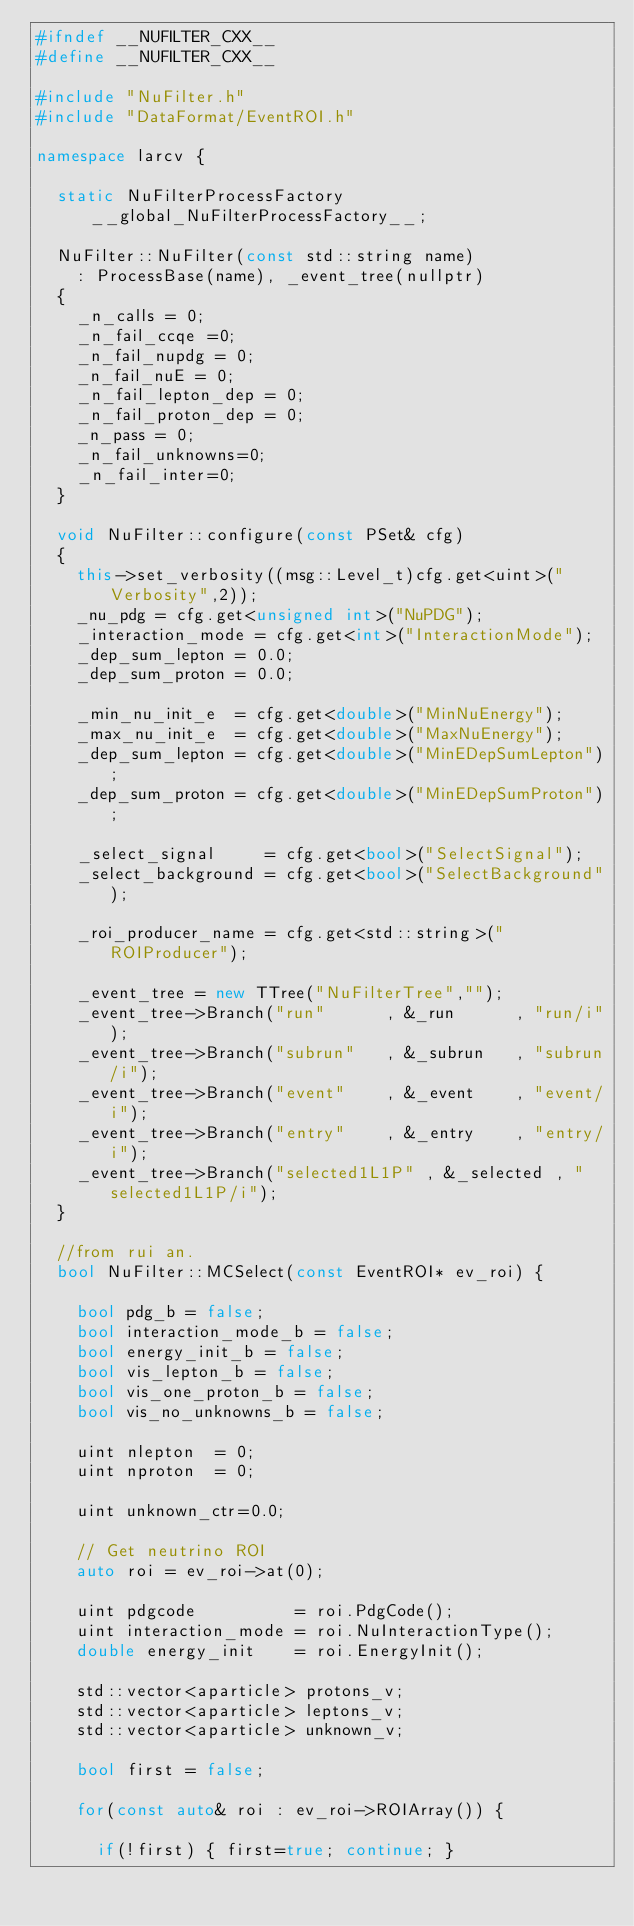Convert code to text. <code><loc_0><loc_0><loc_500><loc_500><_C++_>#ifndef __NUFILTER_CXX__
#define __NUFILTER_CXX__

#include "NuFilter.h"
#include "DataFormat/EventROI.h"

namespace larcv {

  static NuFilterProcessFactory __global_NuFilterProcessFactory__;

  NuFilter::NuFilter(const std::string name)
    : ProcessBase(name), _event_tree(nullptr)
  {
    _n_calls = 0;
    _n_fail_ccqe =0;
    _n_fail_nupdg = 0;
    _n_fail_nuE = 0;
    _n_fail_lepton_dep = 0;
    _n_fail_proton_dep = 0;
    _n_pass = 0;
    _n_fail_unknowns=0;
    _n_fail_inter=0;
  }
    
  void NuFilter::configure(const PSet& cfg)
  {
    this->set_verbosity((msg::Level_t)cfg.get<uint>("Verbosity",2));
    _nu_pdg = cfg.get<unsigned int>("NuPDG");
    _interaction_mode = cfg.get<int>("InteractionMode");
    _dep_sum_lepton = 0.0;
    _dep_sum_proton = 0.0;
    
    _min_nu_init_e  = cfg.get<double>("MinNuEnergy");
    _max_nu_init_e  = cfg.get<double>("MaxNuEnergy");
    _dep_sum_lepton = cfg.get<double>("MinEDepSumLepton");
    _dep_sum_proton = cfg.get<double>("MinEDepSumProton");
    
    _select_signal     = cfg.get<bool>("SelectSignal");
    _select_background = cfg.get<bool>("SelectBackground");

    _roi_producer_name = cfg.get<std::string>("ROIProducer");

    _event_tree = new TTree("NuFilterTree","");
    _event_tree->Branch("run"      , &_run      , "run/i");
    _event_tree->Branch("subrun"   , &_subrun   , "subrun/i");
    _event_tree->Branch("event"    , &_event    , "event/i");
    _event_tree->Branch("entry"    , &_entry    , "entry/i");
    _event_tree->Branch("selected1L1P" , &_selected , "selected1L1P/i");
  }

  //from rui an.
  bool NuFilter::MCSelect(const EventROI* ev_roi) {

    bool pdg_b = false;
    bool interaction_mode_b = false;
    bool energy_init_b = false;
    bool vis_lepton_b = false;
    bool vis_one_proton_b = false;
    bool vis_no_unknowns_b = false;
    
    uint nlepton  = 0;
    uint nproton  = 0;
    
    uint unknown_ctr=0.0;
    
    // Get neutrino ROI
    auto roi = ev_roi->at(0);
    
    uint pdgcode          = roi.PdgCode();
    uint interaction_mode = roi.NuInteractionType();
    double energy_init    = roi.EnergyInit();

    std::vector<aparticle> protons_v;
    std::vector<aparticle> leptons_v;
    std::vector<aparticle> unknown_v;

    bool first = false;
    
    for(const auto& roi : ev_roi->ROIArray()) {

      if(!first) { first=true; continue; }
      </code> 